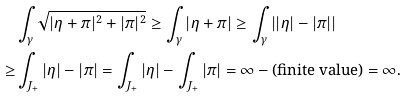<formula> <loc_0><loc_0><loc_500><loc_500>& \int _ { \gamma } \sqrt { | \eta + \pi | ^ { 2 } + | \pi | ^ { 2 } } \geq \int _ { \gamma } | \eta + \pi | \geq \int _ { \gamma } \left | | \eta | - | \pi | \right | \\ \geq & \int _ { J _ { + } } | \eta | - | \pi | = \int _ { J _ { + } } | \eta | - \int _ { J _ { + } } | \pi | = \infty - \text {(finite value)} = \infty .</formula> 